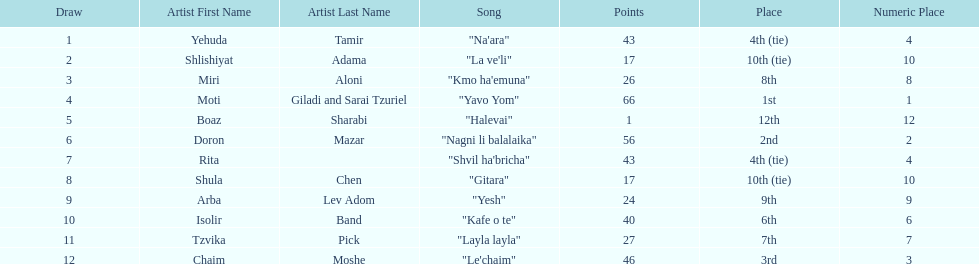What is the total amount of ties in this competition? 2. 